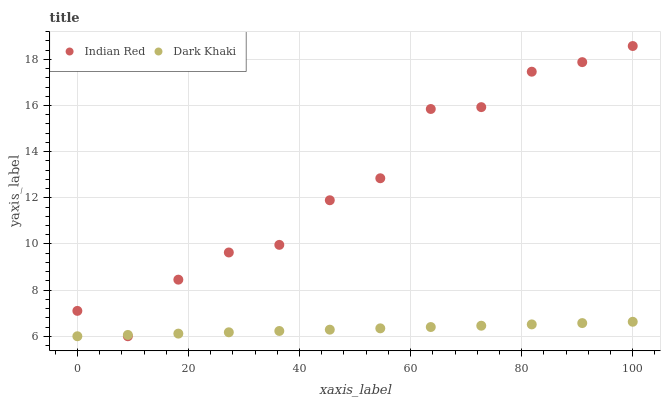Does Dark Khaki have the minimum area under the curve?
Answer yes or no. Yes. Does Indian Red have the maximum area under the curve?
Answer yes or no. Yes. Does Indian Red have the minimum area under the curve?
Answer yes or no. No. Is Dark Khaki the smoothest?
Answer yes or no. Yes. Is Indian Red the roughest?
Answer yes or no. Yes. Is Indian Red the smoothest?
Answer yes or no. No. Does Dark Khaki have the lowest value?
Answer yes or no. Yes. Does Indian Red have the highest value?
Answer yes or no. Yes. Does Indian Red intersect Dark Khaki?
Answer yes or no. Yes. Is Indian Red less than Dark Khaki?
Answer yes or no. No. Is Indian Red greater than Dark Khaki?
Answer yes or no. No. 